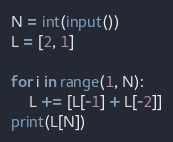Convert code to text. <code><loc_0><loc_0><loc_500><loc_500><_Python_>N = int(input())
L = [2, 1]

for i in range(1, N):
    L += [L[-1] + L[-2]]
print(L[N])</code> 